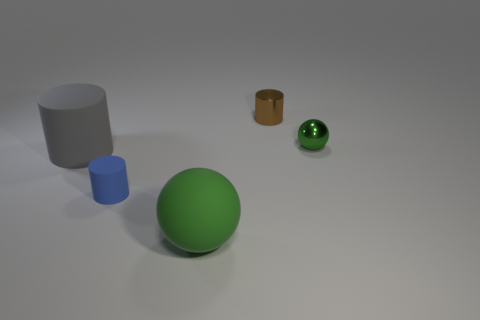Does the blue rubber thing have the same shape as the green matte thing to the right of the small blue rubber thing?
Your response must be concise. No. Is the number of gray rubber cylinders that are behind the small green ball the same as the number of green balls that are to the left of the small brown metallic cylinder?
Give a very brief answer. No. What number of other things are there of the same material as the large sphere
Give a very brief answer. 2. How many rubber objects are large cylinders or cylinders?
Offer a terse response. 2. There is a tiny shiny object in front of the brown metallic cylinder; does it have the same shape as the blue matte thing?
Provide a short and direct response. No. Are there more green balls on the right side of the large green matte sphere than purple matte objects?
Provide a succinct answer. Yes. How many cylinders are both in front of the large cylinder and right of the green rubber ball?
Provide a short and direct response. 0. What is the color of the sphere in front of the green sphere behind the blue rubber cylinder?
Offer a very short reply. Green. What number of metallic objects have the same color as the large cylinder?
Your answer should be compact. 0. Do the tiny sphere and the sphere that is left of the brown metallic object have the same color?
Your answer should be very brief. Yes. 